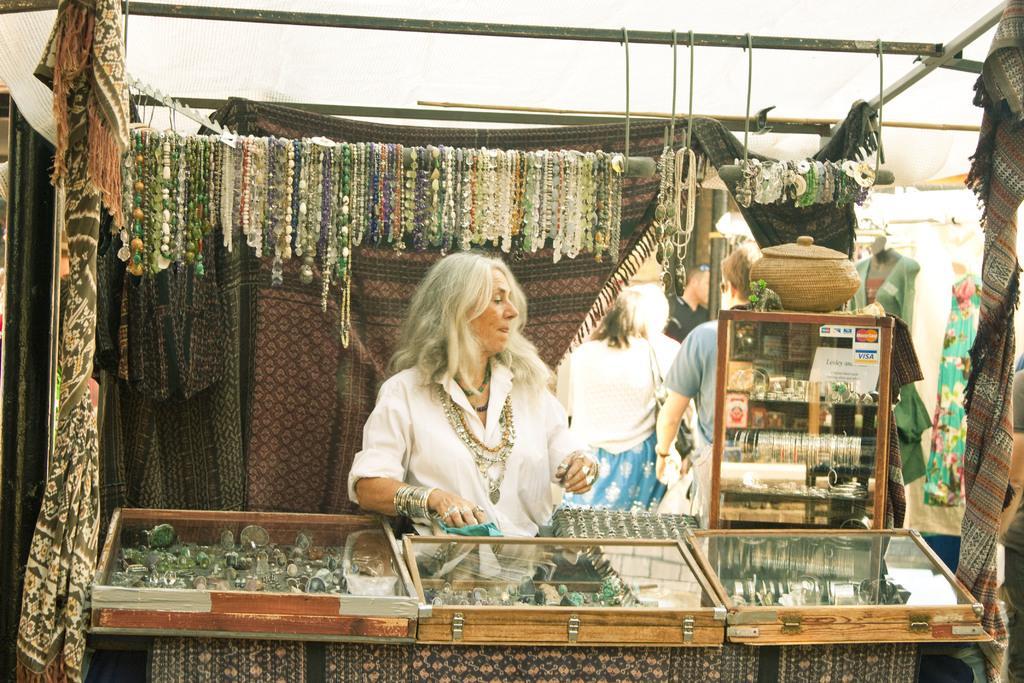Describe this image in one or two sentences. This picture is consists of a jewellery stall in the center of the image and there are people in the center of the image, there are rings, chains, and other items in the stall, there is another stall in the background area of the image, there are curtains in the background area of the image. 